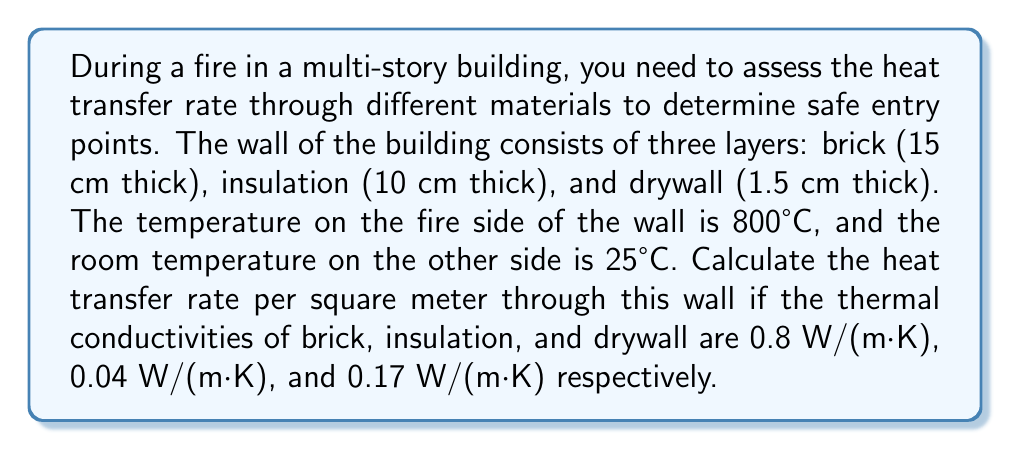Could you help me with this problem? To solve this problem, we'll use the concept of thermal resistance in series for the three layers of the wall. The heat transfer rate can be calculated using Fourier's law of heat conduction.

1. Calculate the thermal resistance of each layer:
   $R = \frac{L}{k}$, where $L$ is thickness and $k$ is thermal conductivity

   Brick: $R_1 = \frac{0.15 \text{ m}}{0.8 \text{ W/(m·K)}} = 0.1875 \text{ m²K/W}$
   Insulation: $R_2 = \frac{0.10 \text{ m}}{0.04 \text{ W/(m·K)}} = 2.5 \text{ m²K/W}$
   Drywall: $R_3 = \frac{0.015 \text{ m}}{0.17 \text{ W/(m·K)}} = 0.0882 \text{ m²K/W}$

2. Calculate the total thermal resistance:
   $R_{\text{total}} = R_1 + R_2 + R_3 = 0.1875 + 2.5 + 0.0882 = 2.7757 \text{ m²K/W}$

3. Calculate the heat transfer rate using Fourier's law:
   $$q = \frac{\Delta T}{R_{\text{total}}}$$

   Where $\Delta T$ is the temperature difference between the fire side and the room side.

   $$q = \frac{800°C - 25°C}{2.7757 \text{ m²K/W}} = \frac{775 \text{ K}}{2.7757 \text{ m²K/W}} = 279.21 \text{ W/m²}$$

Therefore, the heat transfer rate through the wall is approximately 279.21 W/m².
Answer: 279.21 W/m² 